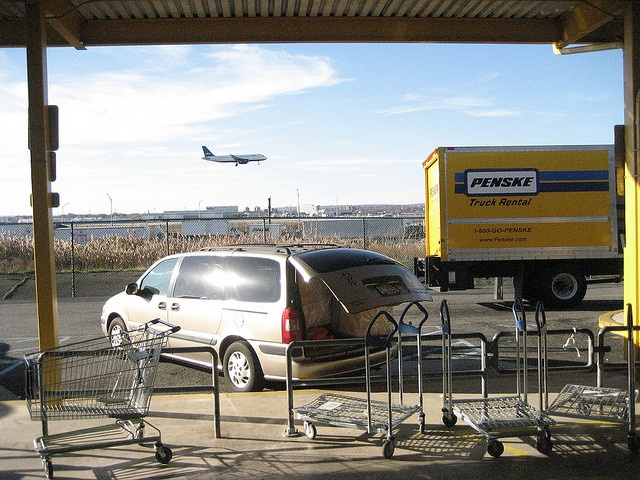Describe the objects in this image and their specific colors. I can see car in black, white, darkgray, and gray tones, truck in black, olive, gray, and khaki tones, and airplane in black, darkgray, gray, and navy tones in this image. 